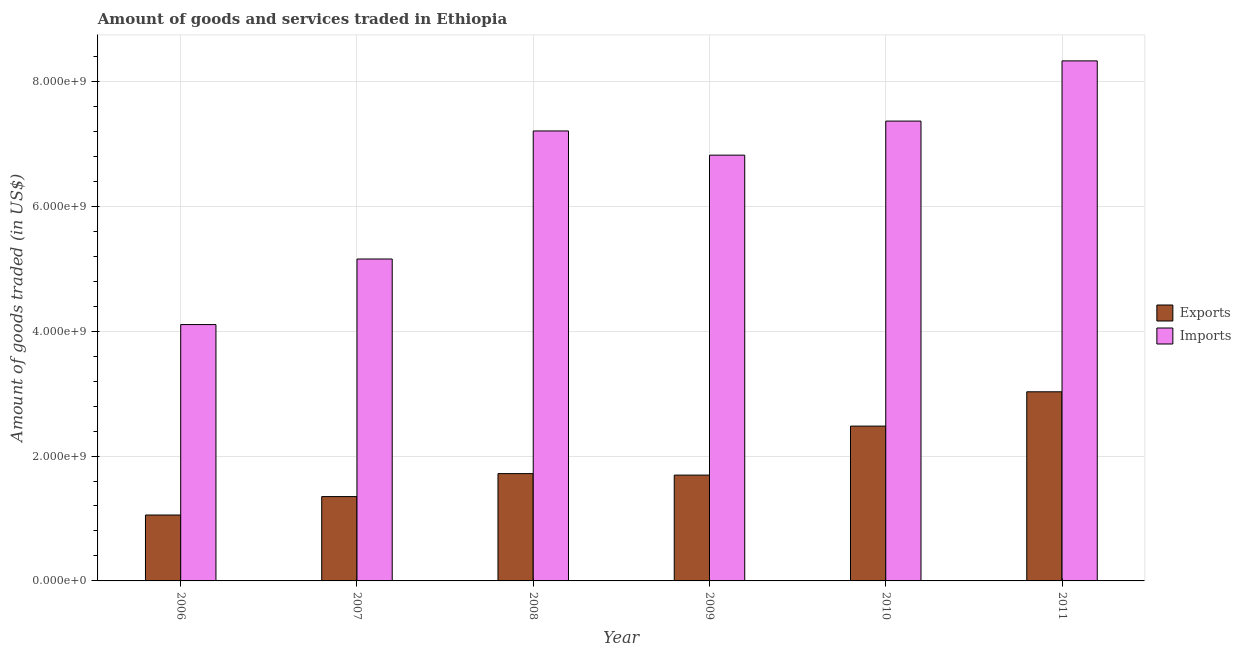How many different coloured bars are there?
Give a very brief answer. 2. How many bars are there on the 6th tick from the left?
Provide a short and direct response. 2. What is the amount of goods exported in 2011?
Provide a succinct answer. 3.03e+09. Across all years, what is the maximum amount of goods imported?
Your answer should be compact. 8.33e+09. Across all years, what is the minimum amount of goods exported?
Ensure brevity in your answer.  1.06e+09. In which year was the amount of goods imported maximum?
Your answer should be compact. 2011. What is the total amount of goods exported in the graph?
Your response must be concise. 1.13e+1. What is the difference between the amount of goods imported in 2007 and that in 2011?
Your answer should be compact. -3.17e+09. What is the difference between the amount of goods imported in 2006 and the amount of goods exported in 2010?
Make the answer very short. -3.26e+09. What is the average amount of goods imported per year?
Your answer should be very brief. 6.50e+09. In the year 2009, what is the difference between the amount of goods imported and amount of goods exported?
Offer a very short reply. 0. What is the ratio of the amount of goods imported in 2006 to that in 2011?
Provide a short and direct response. 0.49. Is the difference between the amount of goods exported in 2006 and 2008 greater than the difference between the amount of goods imported in 2006 and 2008?
Provide a short and direct response. No. What is the difference between the highest and the second highest amount of goods imported?
Offer a terse response. 9.64e+08. What is the difference between the highest and the lowest amount of goods exported?
Offer a terse response. 1.97e+09. What does the 1st bar from the left in 2008 represents?
Ensure brevity in your answer.  Exports. What does the 1st bar from the right in 2011 represents?
Provide a short and direct response. Imports. How many bars are there?
Ensure brevity in your answer.  12. Are all the bars in the graph horizontal?
Your answer should be compact. No. How many years are there in the graph?
Provide a succinct answer. 6. What is the difference between two consecutive major ticks on the Y-axis?
Make the answer very short. 2.00e+09. How many legend labels are there?
Your answer should be very brief. 2. What is the title of the graph?
Offer a terse response. Amount of goods and services traded in Ethiopia. What is the label or title of the X-axis?
Keep it short and to the point. Year. What is the label or title of the Y-axis?
Provide a succinct answer. Amount of goods traded (in US$). What is the Amount of goods traded (in US$) of Exports in 2006?
Ensure brevity in your answer.  1.06e+09. What is the Amount of goods traded (in US$) of Imports in 2006?
Offer a terse response. 4.11e+09. What is the Amount of goods traded (in US$) in Exports in 2007?
Your answer should be compact. 1.35e+09. What is the Amount of goods traded (in US$) of Imports in 2007?
Your answer should be compact. 5.16e+09. What is the Amount of goods traded (in US$) of Exports in 2008?
Your answer should be compact. 1.72e+09. What is the Amount of goods traded (in US$) of Imports in 2008?
Offer a very short reply. 7.21e+09. What is the Amount of goods traded (in US$) in Exports in 2009?
Offer a terse response. 1.69e+09. What is the Amount of goods traded (in US$) of Imports in 2009?
Your response must be concise. 6.82e+09. What is the Amount of goods traded (in US$) of Exports in 2010?
Keep it short and to the point. 2.48e+09. What is the Amount of goods traded (in US$) of Imports in 2010?
Your answer should be very brief. 7.36e+09. What is the Amount of goods traded (in US$) in Exports in 2011?
Provide a short and direct response. 3.03e+09. What is the Amount of goods traded (in US$) in Imports in 2011?
Offer a very short reply. 8.33e+09. Across all years, what is the maximum Amount of goods traded (in US$) in Exports?
Your answer should be compact. 3.03e+09. Across all years, what is the maximum Amount of goods traded (in US$) of Imports?
Provide a succinct answer. 8.33e+09. Across all years, what is the minimum Amount of goods traded (in US$) in Exports?
Give a very brief answer. 1.06e+09. Across all years, what is the minimum Amount of goods traded (in US$) of Imports?
Offer a very short reply. 4.11e+09. What is the total Amount of goods traded (in US$) in Exports in the graph?
Keep it short and to the point. 1.13e+1. What is the total Amount of goods traded (in US$) of Imports in the graph?
Your answer should be very brief. 3.90e+1. What is the difference between the Amount of goods traded (in US$) of Exports in 2006 and that in 2007?
Offer a terse response. -2.95e+08. What is the difference between the Amount of goods traded (in US$) of Imports in 2006 and that in 2007?
Provide a short and direct response. -1.05e+09. What is the difference between the Amount of goods traded (in US$) of Exports in 2006 and that in 2008?
Offer a very short reply. -6.63e+08. What is the difference between the Amount of goods traded (in US$) of Imports in 2006 and that in 2008?
Keep it short and to the point. -3.10e+09. What is the difference between the Amount of goods traded (in US$) of Exports in 2006 and that in 2009?
Ensure brevity in your answer.  -6.39e+08. What is the difference between the Amount of goods traded (in US$) of Imports in 2006 and that in 2009?
Your response must be concise. -2.71e+09. What is the difference between the Amount of goods traded (in US$) in Exports in 2006 and that in 2010?
Offer a very short reply. -1.42e+09. What is the difference between the Amount of goods traded (in US$) in Imports in 2006 and that in 2010?
Your answer should be very brief. -3.26e+09. What is the difference between the Amount of goods traded (in US$) in Exports in 2006 and that in 2011?
Your response must be concise. -1.97e+09. What is the difference between the Amount of goods traded (in US$) of Imports in 2006 and that in 2011?
Give a very brief answer. -4.22e+09. What is the difference between the Amount of goods traded (in US$) of Exports in 2007 and that in 2008?
Keep it short and to the point. -3.68e+08. What is the difference between the Amount of goods traded (in US$) in Imports in 2007 and that in 2008?
Ensure brevity in your answer.  -2.05e+09. What is the difference between the Amount of goods traded (in US$) in Exports in 2007 and that in 2009?
Your answer should be compact. -3.44e+08. What is the difference between the Amount of goods traded (in US$) in Imports in 2007 and that in 2009?
Give a very brief answer. -1.66e+09. What is the difference between the Amount of goods traded (in US$) in Exports in 2007 and that in 2010?
Your response must be concise. -1.13e+09. What is the difference between the Amount of goods traded (in US$) of Imports in 2007 and that in 2010?
Your response must be concise. -2.21e+09. What is the difference between the Amount of goods traded (in US$) in Exports in 2007 and that in 2011?
Your answer should be very brief. -1.68e+09. What is the difference between the Amount of goods traded (in US$) of Imports in 2007 and that in 2011?
Your answer should be very brief. -3.17e+09. What is the difference between the Amount of goods traded (in US$) of Exports in 2008 and that in 2009?
Provide a short and direct response. 2.39e+07. What is the difference between the Amount of goods traded (in US$) in Imports in 2008 and that in 2009?
Your response must be concise. 3.87e+08. What is the difference between the Amount of goods traded (in US$) of Exports in 2008 and that in 2010?
Give a very brief answer. -7.61e+08. What is the difference between the Amount of goods traded (in US$) in Imports in 2008 and that in 2010?
Provide a short and direct response. -1.58e+08. What is the difference between the Amount of goods traded (in US$) of Exports in 2008 and that in 2011?
Give a very brief answer. -1.31e+09. What is the difference between the Amount of goods traded (in US$) of Imports in 2008 and that in 2011?
Give a very brief answer. -1.12e+09. What is the difference between the Amount of goods traded (in US$) in Exports in 2009 and that in 2010?
Your answer should be compact. -7.85e+08. What is the difference between the Amount of goods traded (in US$) of Imports in 2009 and that in 2010?
Provide a short and direct response. -5.45e+08. What is the difference between the Amount of goods traded (in US$) of Exports in 2009 and that in 2011?
Offer a terse response. -1.33e+09. What is the difference between the Amount of goods traded (in US$) in Imports in 2009 and that in 2011?
Make the answer very short. -1.51e+09. What is the difference between the Amount of goods traded (in US$) in Exports in 2010 and that in 2011?
Your response must be concise. -5.50e+08. What is the difference between the Amount of goods traded (in US$) in Imports in 2010 and that in 2011?
Your answer should be very brief. -9.64e+08. What is the difference between the Amount of goods traded (in US$) in Exports in 2006 and the Amount of goods traded (in US$) in Imports in 2007?
Ensure brevity in your answer.  -4.10e+09. What is the difference between the Amount of goods traded (in US$) in Exports in 2006 and the Amount of goods traded (in US$) in Imports in 2008?
Keep it short and to the point. -6.15e+09. What is the difference between the Amount of goods traded (in US$) of Exports in 2006 and the Amount of goods traded (in US$) of Imports in 2009?
Offer a very short reply. -5.76e+09. What is the difference between the Amount of goods traded (in US$) of Exports in 2006 and the Amount of goods traded (in US$) of Imports in 2010?
Offer a terse response. -6.31e+09. What is the difference between the Amount of goods traded (in US$) in Exports in 2006 and the Amount of goods traded (in US$) in Imports in 2011?
Give a very brief answer. -7.27e+09. What is the difference between the Amount of goods traded (in US$) of Exports in 2007 and the Amount of goods traded (in US$) of Imports in 2008?
Provide a short and direct response. -5.86e+09. What is the difference between the Amount of goods traded (in US$) in Exports in 2007 and the Amount of goods traded (in US$) in Imports in 2009?
Your answer should be very brief. -5.47e+09. What is the difference between the Amount of goods traded (in US$) in Exports in 2007 and the Amount of goods traded (in US$) in Imports in 2010?
Your response must be concise. -6.01e+09. What is the difference between the Amount of goods traded (in US$) in Exports in 2007 and the Amount of goods traded (in US$) in Imports in 2011?
Give a very brief answer. -6.98e+09. What is the difference between the Amount of goods traded (in US$) in Exports in 2008 and the Amount of goods traded (in US$) in Imports in 2009?
Provide a short and direct response. -5.10e+09. What is the difference between the Amount of goods traded (in US$) of Exports in 2008 and the Amount of goods traded (in US$) of Imports in 2010?
Your response must be concise. -5.65e+09. What is the difference between the Amount of goods traded (in US$) in Exports in 2008 and the Amount of goods traded (in US$) in Imports in 2011?
Ensure brevity in your answer.  -6.61e+09. What is the difference between the Amount of goods traded (in US$) in Exports in 2009 and the Amount of goods traded (in US$) in Imports in 2010?
Offer a very short reply. -5.67e+09. What is the difference between the Amount of goods traded (in US$) in Exports in 2009 and the Amount of goods traded (in US$) in Imports in 2011?
Your answer should be compact. -6.63e+09. What is the difference between the Amount of goods traded (in US$) of Exports in 2010 and the Amount of goods traded (in US$) of Imports in 2011?
Offer a very short reply. -5.85e+09. What is the average Amount of goods traded (in US$) of Exports per year?
Make the answer very short. 1.89e+09. What is the average Amount of goods traded (in US$) of Imports per year?
Your answer should be very brief. 6.50e+09. In the year 2006, what is the difference between the Amount of goods traded (in US$) of Exports and Amount of goods traded (in US$) of Imports?
Offer a very short reply. -3.05e+09. In the year 2007, what is the difference between the Amount of goods traded (in US$) of Exports and Amount of goods traded (in US$) of Imports?
Offer a very short reply. -3.80e+09. In the year 2008, what is the difference between the Amount of goods traded (in US$) of Exports and Amount of goods traded (in US$) of Imports?
Give a very brief answer. -5.49e+09. In the year 2009, what is the difference between the Amount of goods traded (in US$) in Exports and Amount of goods traded (in US$) in Imports?
Your response must be concise. -5.12e+09. In the year 2010, what is the difference between the Amount of goods traded (in US$) in Exports and Amount of goods traded (in US$) in Imports?
Provide a succinct answer. -4.89e+09. In the year 2011, what is the difference between the Amount of goods traded (in US$) in Exports and Amount of goods traded (in US$) in Imports?
Provide a short and direct response. -5.30e+09. What is the ratio of the Amount of goods traded (in US$) of Exports in 2006 to that in 2007?
Provide a succinct answer. 0.78. What is the ratio of the Amount of goods traded (in US$) of Imports in 2006 to that in 2007?
Provide a short and direct response. 0.8. What is the ratio of the Amount of goods traded (in US$) of Exports in 2006 to that in 2008?
Offer a terse response. 0.61. What is the ratio of the Amount of goods traded (in US$) of Imports in 2006 to that in 2008?
Offer a very short reply. 0.57. What is the ratio of the Amount of goods traded (in US$) in Exports in 2006 to that in 2009?
Make the answer very short. 0.62. What is the ratio of the Amount of goods traded (in US$) in Imports in 2006 to that in 2009?
Provide a succinct answer. 0.6. What is the ratio of the Amount of goods traded (in US$) in Exports in 2006 to that in 2010?
Ensure brevity in your answer.  0.43. What is the ratio of the Amount of goods traded (in US$) in Imports in 2006 to that in 2010?
Offer a very short reply. 0.56. What is the ratio of the Amount of goods traded (in US$) in Exports in 2006 to that in 2011?
Your answer should be compact. 0.35. What is the ratio of the Amount of goods traded (in US$) of Imports in 2006 to that in 2011?
Offer a very short reply. 0.49. What is the ratio of the Amount of goods traded (in US$) of Exports in 2007 to that in 2008?
Provide a succinct answer. 0.79. What is the ratio of the Amount of goods traded (in US$) of Imports in 2007 to that in 2008?
Give a very brief answer. 0.72. What is the ratio of the Amount of goods traded (in US$) of Exports in 2007 to that in 2009?
Your answer should be very brief. 0.8. What is the ratio of the Amount of goods traded (in US$) of Imports in 2007 to that in 2009?
Offer a terse response. 0.76. What is the ratio of the Amount of goods traded (in US$) of Exports in 2007 to that in 2010?
Provide a succinct answer. 0.54. What is the ratio of the Amount of goods traded (in US$) of Imports in 2007 to that in 2010?
Your response must be concise. 0.7. What is the ratio of the Amount of goods traded (in US$) of Exports in 2007 to that in 2011?
Offer a very short reply. 0.45. What is the ratio of the Amount of goods traded (in US$) in Imports in 2007 to that in 2011?
Your response must be concise. 0.62. What is the ratio of the Amount of goods traded (in US$) of Exports in 2008 to that in 2009?
Your answer should be very brief. 1.01. What is the ratio of the Amount of goods traded (in US$) in Imports in 2008 to that in 2009?
Your answer should be very brief. 1.06. What is the ratio of the Amount of goods traded (in US$) in Exports in 2008 to that in 2010?
Provide a succinct answer. 0.69. What is the ratio of the Amount of goods traded (in US$) of Imports in 2008 to that in 2010?
Provide a succinct answer. 0.98. What is the ratio of the Amount of goods traded (in US$) of Exports in 2008 to that in 2011?
Make the answer very short. 0.57. What is the ratio of the Amount of goods traded (in US$) in Imports in 2008 to that in 2011?
Your answer should be compact. 0.87. What is the ratio of the Amount of goods traded (in US$) in Exports in 2009 to that in 2010?
Give a very brief answer. 0.68. What is the ratio of the Amount of goods traded (in US$) in Imports in 2009 to that in 2010?
Keep it short and to the point. 0.93. What is the ratio of the Amount of goods traded (in US$) of Exports in 2009 to that in 2011?
Offer a terse response. 0.56. What is the ratio of the Amount of goods traded (in US$) in Imports in 2009 to that in 2011?
Offer a very short reply. 0.82. What is the ratio of the Amount of goods traded (in US$) of Exports in 2010 to that in 2011?
Provide a succinct answer. 0.82. What is the ratio of the Amount of goods traded (in US$) in Imports in 2010 to that in 2011?
Give a very brief answer. 0.88. What is the difference between the highest and the second highest Amount of goods traded (in US$) in Exports?
Make the answer very short. 5.50e+08. What is the difference between the highest and the second highest Amount of goods traded (in US$) of Imports?
Provide a short and direct response. 9.64e+08. What is the difference between the highest and the lowest Amount of goods traded (in US$) of Exports?
Keep it short and to the point. 1.97e+09. What is the difference between the highest and the lowest Amount of goods traded (in US$) in Imports?
Provide a short and direct response. 4.22e+09. 